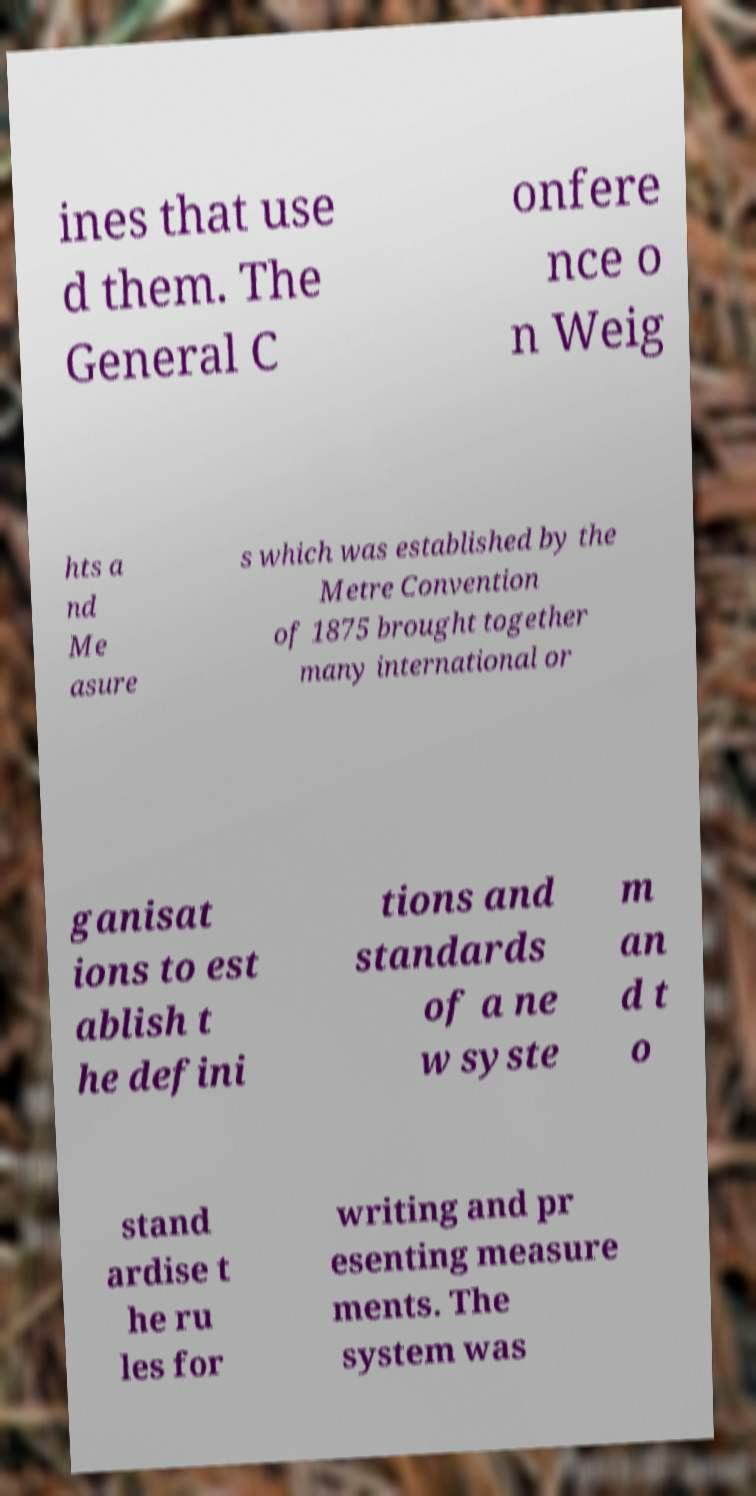I need the written content from this picture converted into text. Can you do that? ines that use d them. The General C onfere nce o n Weig hts a nd Me asure s which was established by the Metre Convention of 1875 brought together many international or ganisat ions to est ablish t he defini tions and standards of a ne w syste m an d t o stand ardise t he ru les for writing and pr esenting measure ments. The system was 